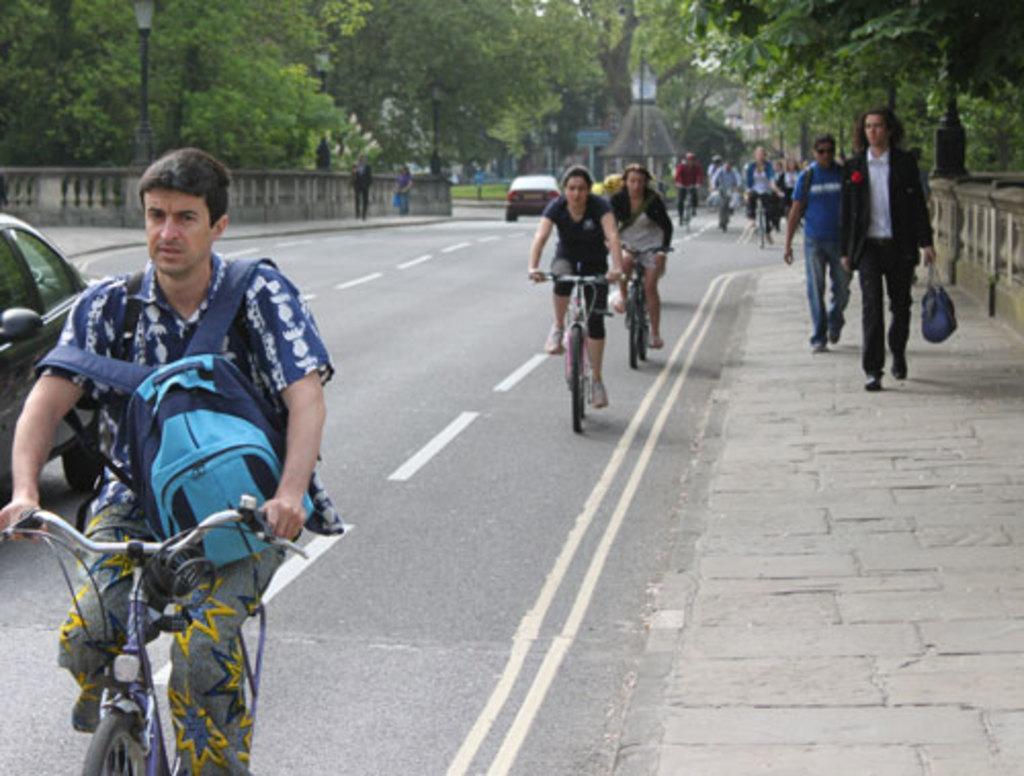In one or two sentences, can you explain what this image depicts? This picture shows few people riding bicycles and we see a couple of people walking on the sidewalk and a man holding a bag in his hand and we see cars moving on the road and we see trees around 